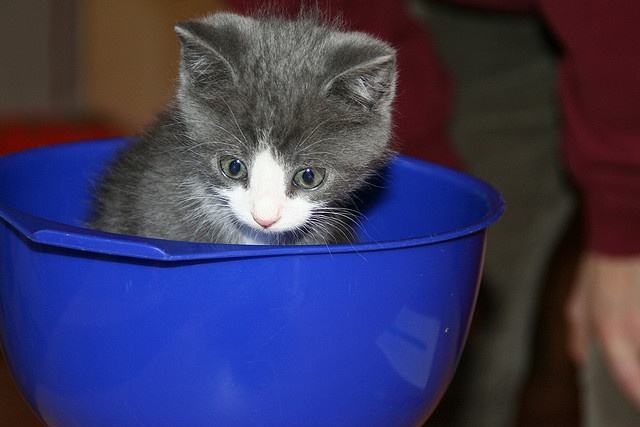Describe the objects in this image and their specific colors. I can see bowl in black, darkblue, blue, and navy tones, cat in black, gray, darkgray, and white tones, and people in black, maroon, gray, and brown tones in this image. 